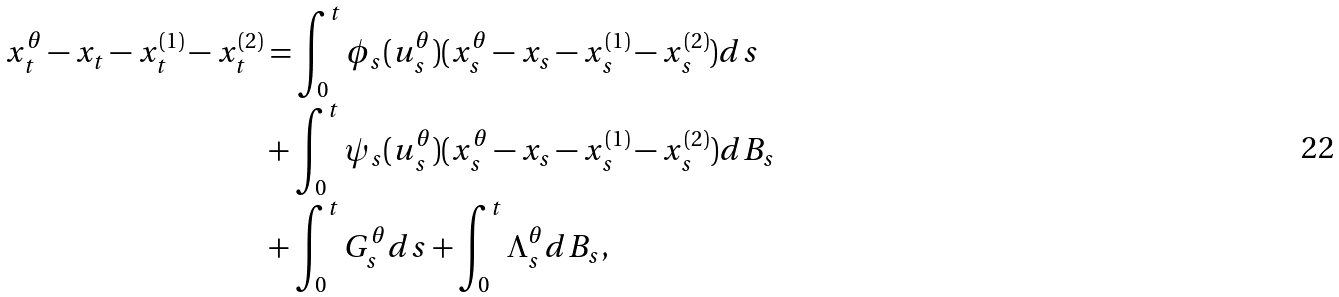Convert formula to latex. <formula><loc_0><loc_0><loc_500><loc_500>x ^ { \theta } _ { t } - x _ { t } - x _ { t } ^ { ( 1 ) } - x _ { t } ^ { ( 2 ) } & = \int _ { 0 } ^ { t } \phi _ { s } ( u ^ { \theta } _ { s } ) ( x ^ { \theta } _ { s } - x _ { s } - x _ { s } ^ { ( 1 ) } - x _ { s } ^ { ( 2 ) } ) d s \\ & + \int _ { 0 } ^ { t } \psi _ { s } ( u ^ { \theta } _ { s } ) ( x ^ { \theta } _ { s } - x _ { s } - x _ { s } ^ { ( 1 ) } - x _ { s } ^ { ( 2 ) } ) d B _ { s } \\ & + \int _ { 0 } ^ { t } G ^ { \theta } _ { s } d s + \int _ { 0 } ^ { t } \Lambda _ { s } ^ { \theta } d B _ { s } ,</formula> 